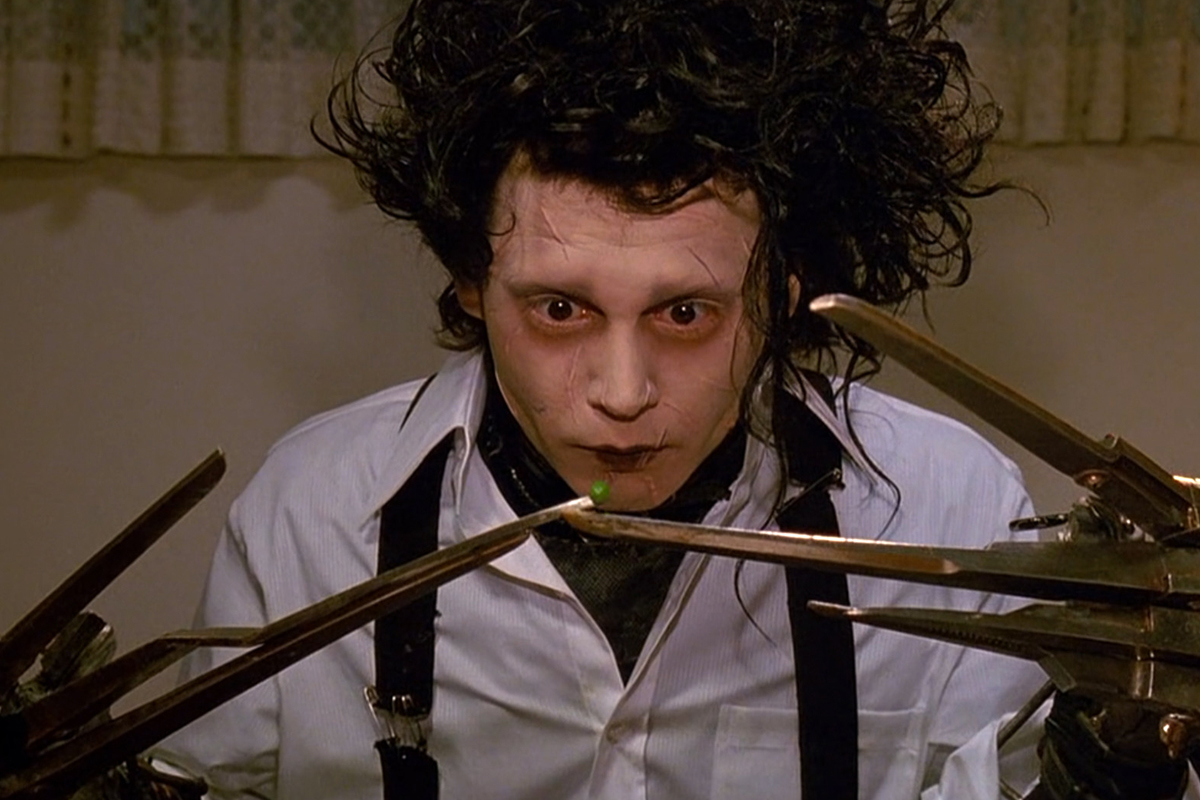Can you explain the significance of Edward's appearance? Edward's appearance is laden with symbolism and intricately ties into the narrative of the film. His pale complexion and dark, brooding eyes reflect his isolation and the internal sadness he harbors due to his unique condition. The spiky, unkempt hair adds to his otherworldly look, distancing him from the other characters. His scissor hands are the most striking feature, symbolizing both his potential for creativity and the inherent danger they present. These attributes make Edward a figure of fascination and empathy, illustrating themes of nonconformity and the deep-seated human desire for connection. Why do you think Edward often looks so sad? Edward's sadness arises from his intense feelings of loneliness and his struggle to fit into a world that views him with suspicion and fear. Created by an inventor who died before completing him, Edward was left with scissor hands, making him an incomplete and tragic figure. His appearance and abilities make him a social outcast, leading to his deep-seated melancholia. Despite his kind nature and artistic talent, Edward's inability to physically connect with others exacerbates his emotional isolation, manifesting as an inherent sadness in his expression. 